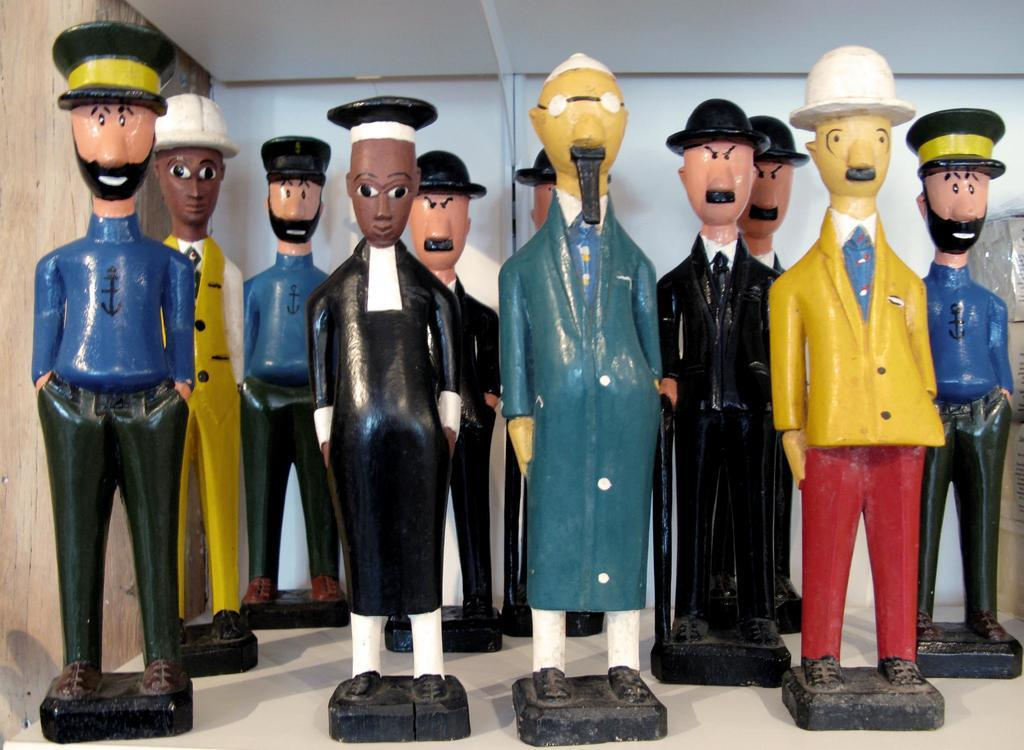What objects are present in the image? There are toys in the image. What distinguishing feature do the toys have? The toys are wearing caps. Where are the toys located in the image? The toys are on a surface. What type of flesh can be seen on the toys in the image? There is no flesh present on the toys in the image, as they are likely made of plastic or another inanimate material. 